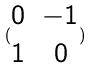Convert formula to latex. <formula><loc_0><loc_0><loc_500><loc_500>( \begin{matrix} 0 & - 1 \\ 1 & 0 \end{matrix} )</formula> 